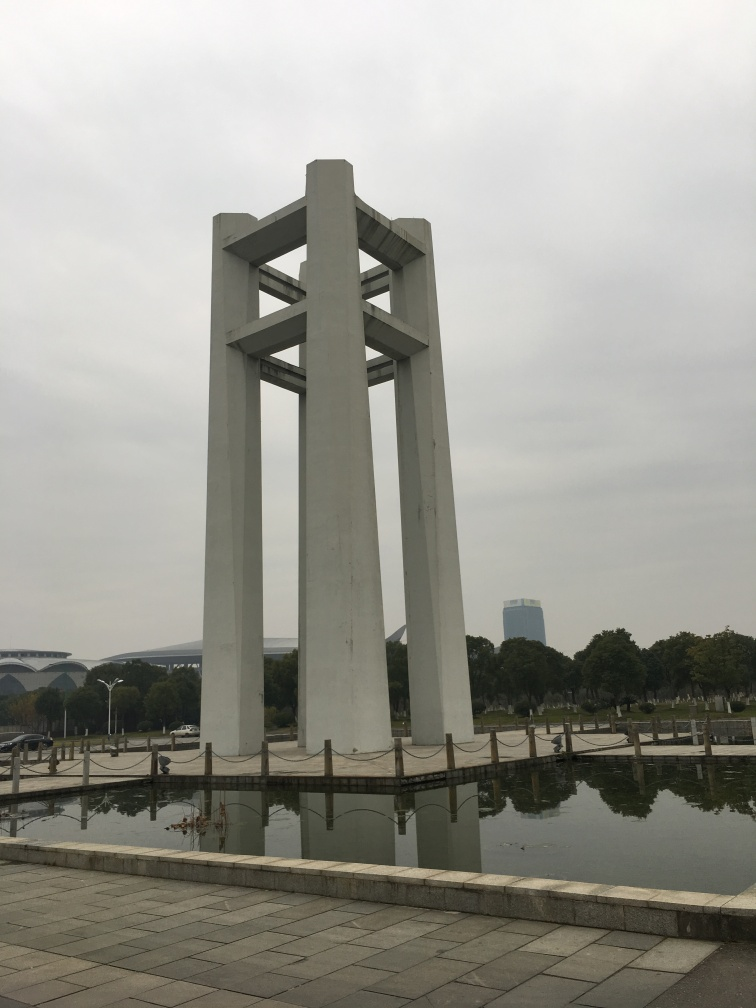Can you describe the surrounding environment? Certainly! Surrounding the focal structure is a serene body of water, reflecting the image of the structure and nearby trees, amplifying the tranquility of the scene. The overcast sky suggests a cool and calm day. Paved walkways invite visitors for a stroll, and the distant architecture indicates that this peaceful area is within or near an urban setting. 